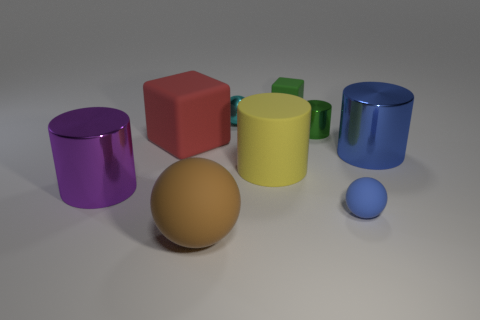What materials do the objects in the image look like they are made of? The objects in the image appear to be made of various materials. The purple and blue objects have a reflective surface that suggests they may be made of a glossy plastic or ceramic. The red and green cubes look to have a matte finish, which could indicate a material like rubber or matte plastic. The small and large spheres appear to also have a matte texture, consistent with a rubbery material. 